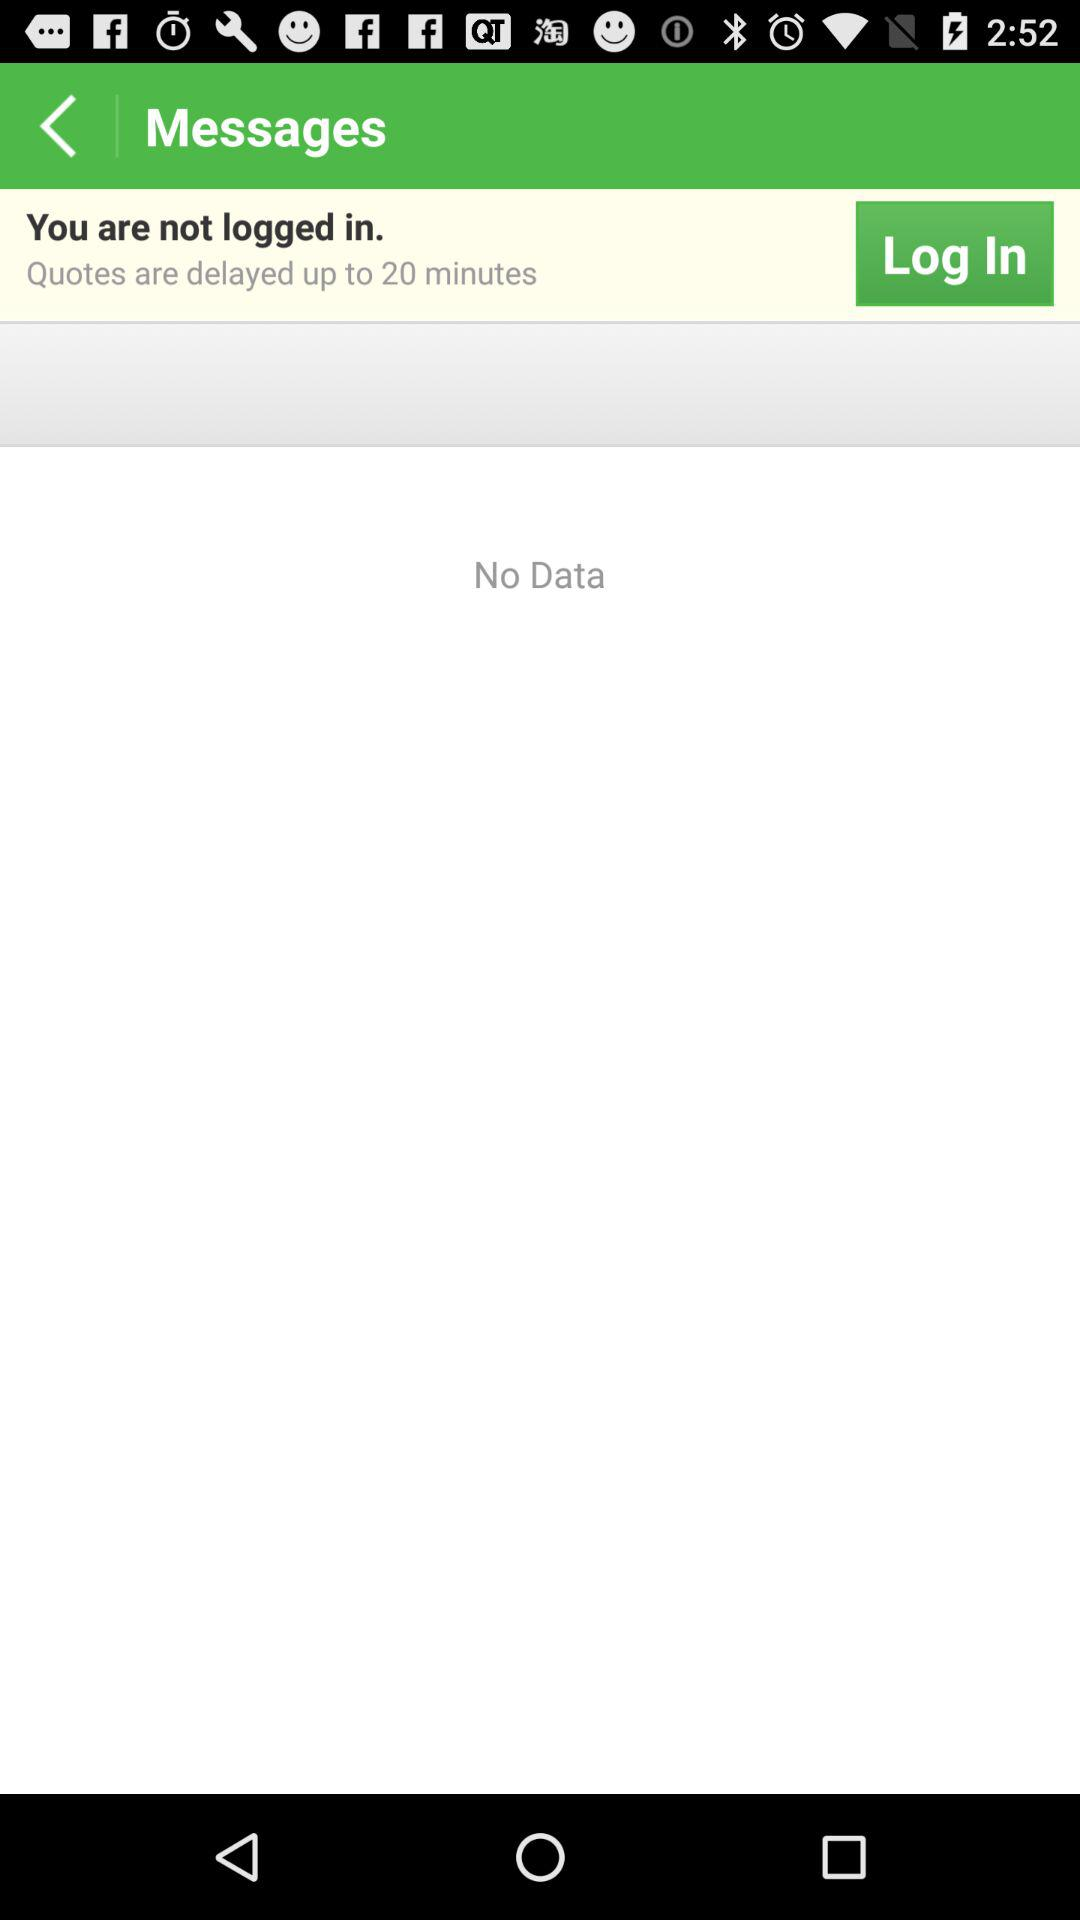How long are quotes delayed? Quotes are delayed by up to 20 minutes. 